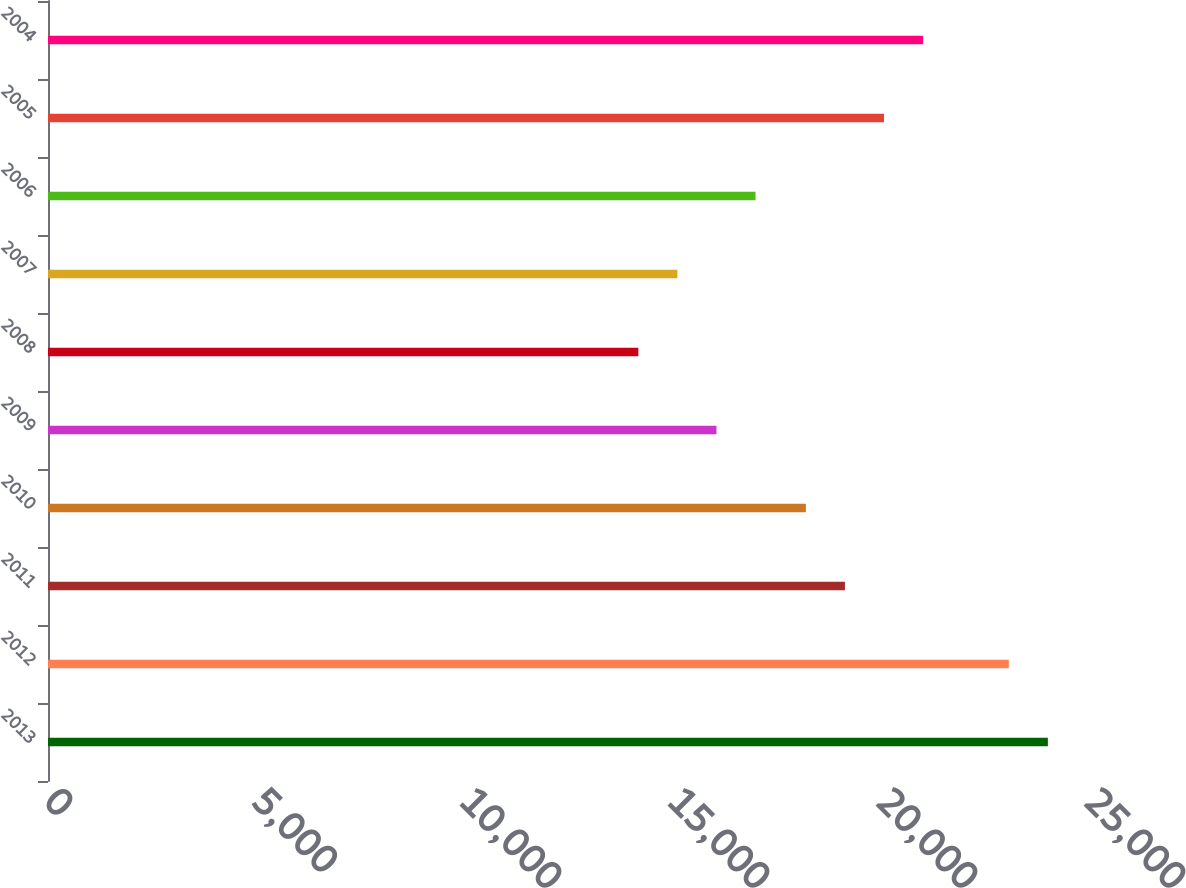Convert chart. <chart><loc_0><loc_0><loc_500><loc_500><bar_chart><fcel>2013<fcel>2012<fcel>2011<fcel>2010<fcel>2009<fcel>2008<fcel>2007<fcel>2006<fcel>2005<fcel>2004<nl><fcel>24035.1<fcel>23096<fcel>19157.1<fcel>18218<fcel>16069.2<fcel>14191<fcel>15130.1<fcel>17008.3<fcel>20096.2<fcel>21035.3<nl></chart> 